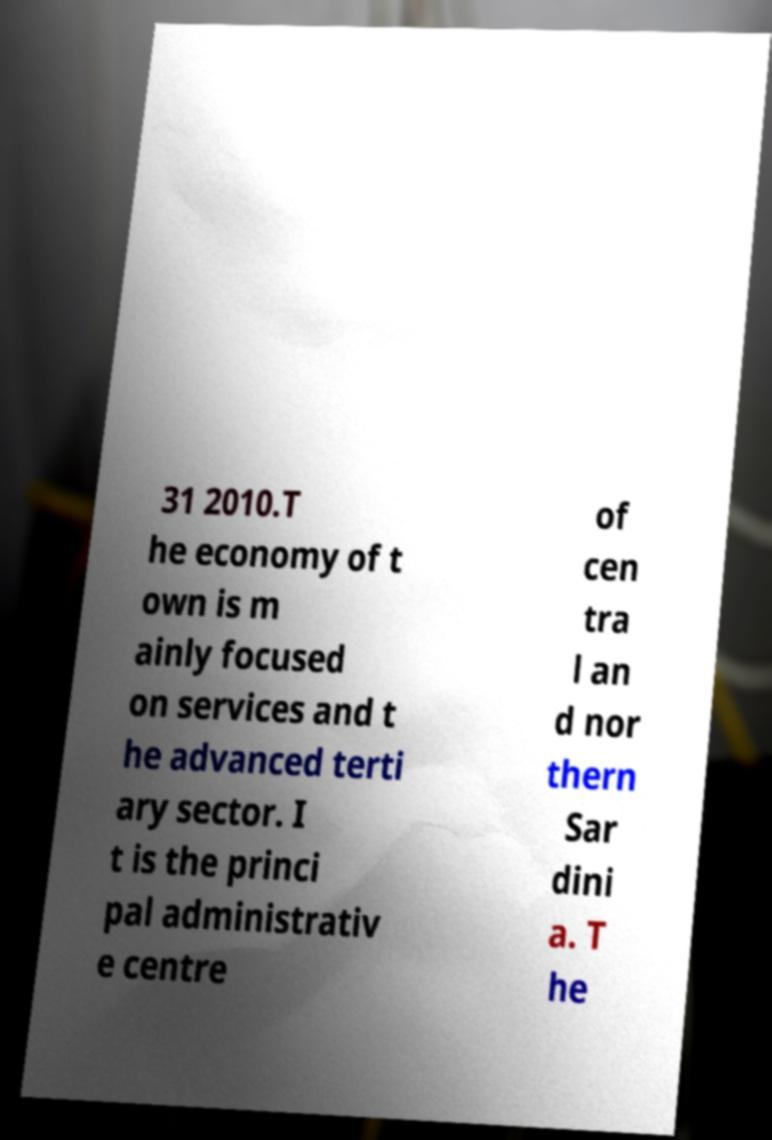What messages or text are displayed in this image? I need them in a readable, typed format. 31 2010.T he economy of t own is m ainly focused on services and t he advanced terti ary sector. I t is the princi pal administrativ e centre of cen tra l an d nor thern Sar dini a. T he 